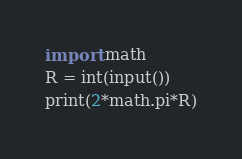<code> <loc_0><loc_0><loc_500><loc_500><_Python_>import math
R = int(input())
print(2*math.pi*R)</code> 